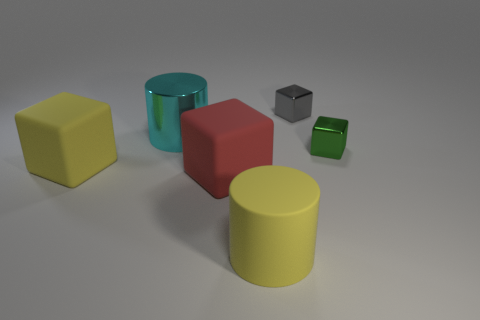Can you describe the lighting in this scene? The scene is softly lit from above, casting gentle shadows beneath the objects, indicating a likely indoor environment with a single, diffused light source. 